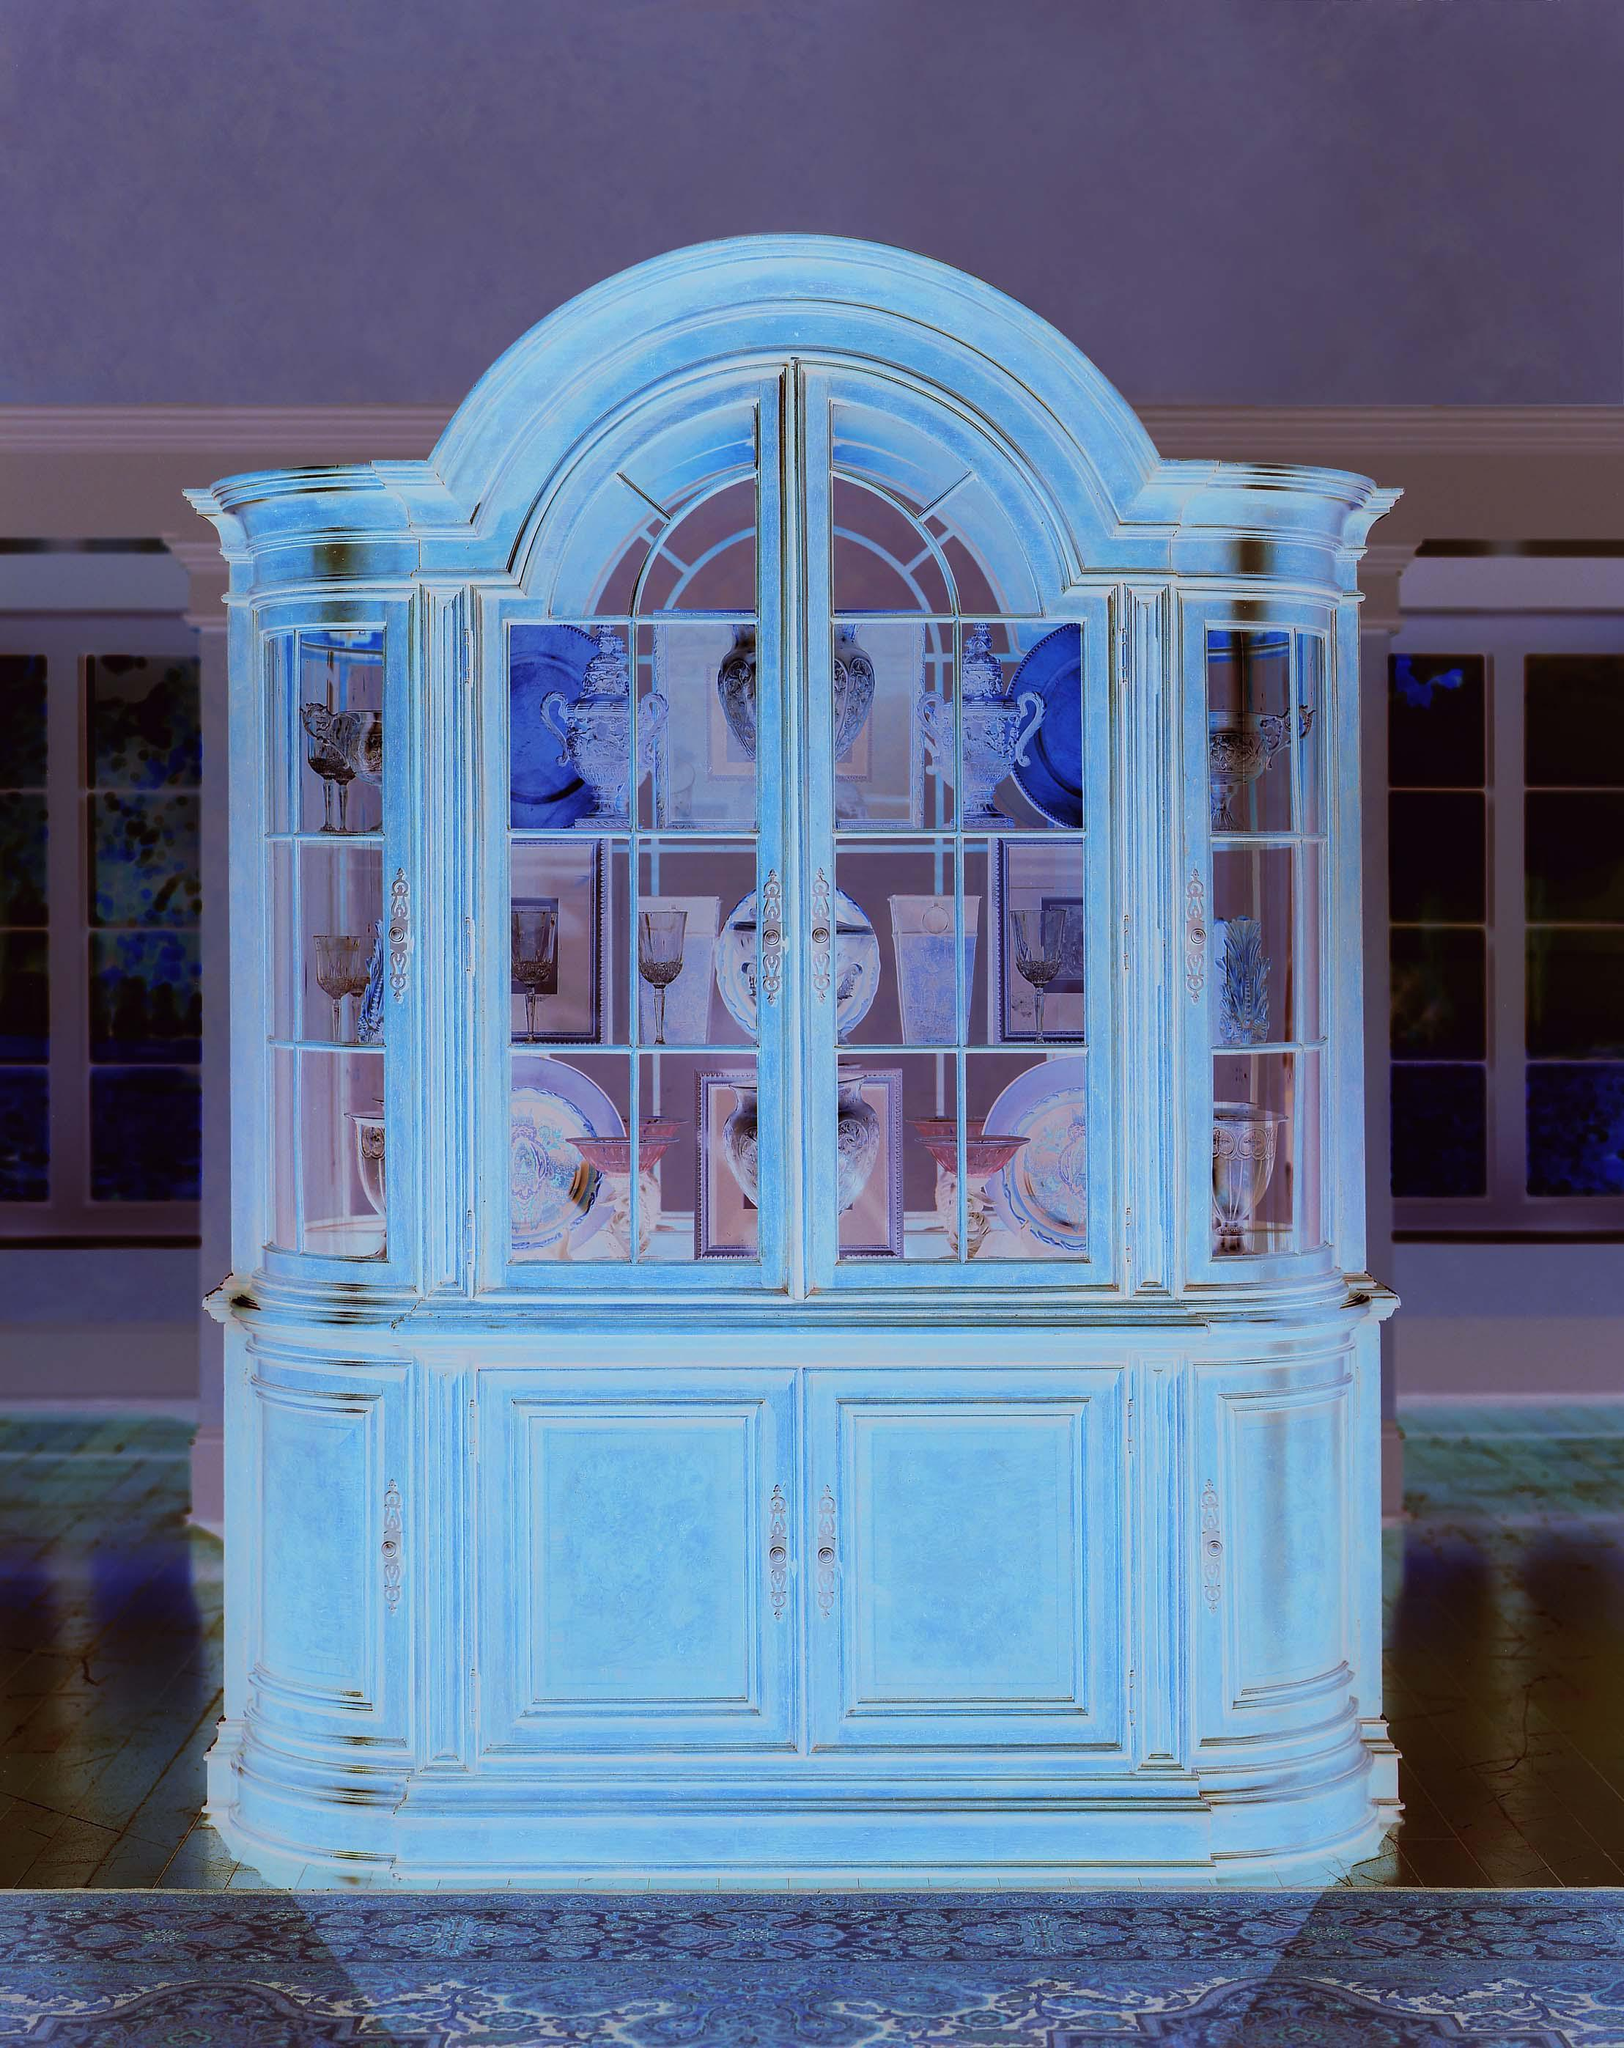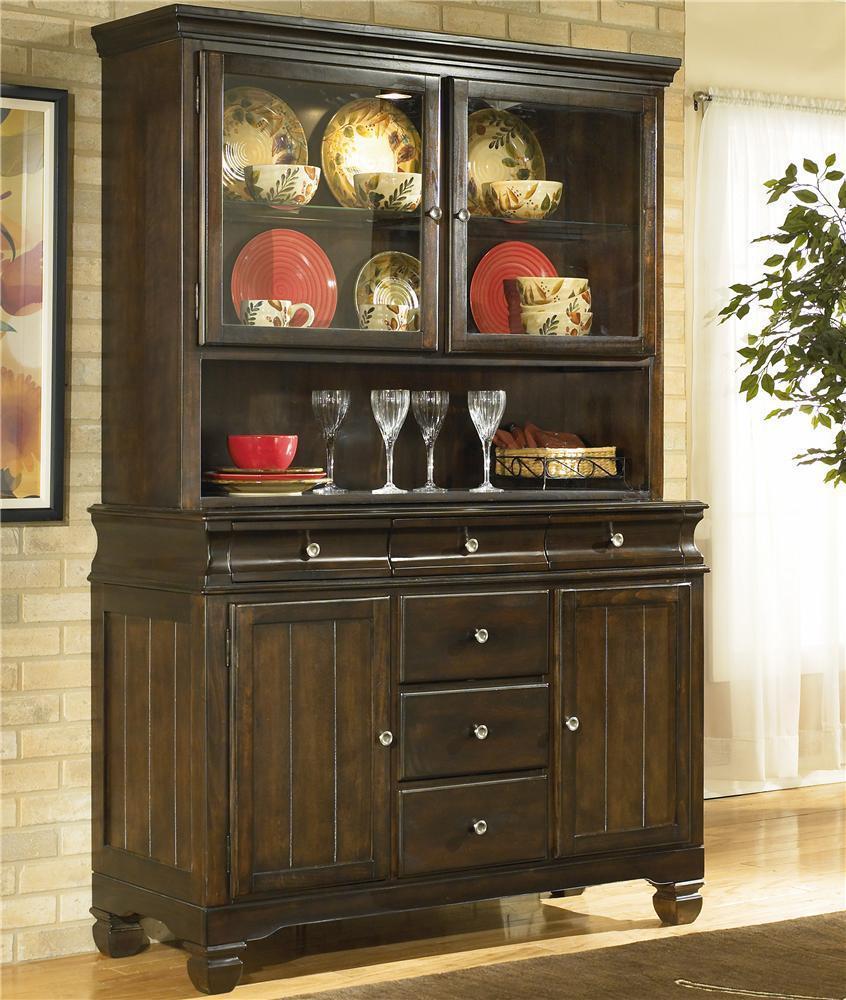The first image is the image on the left, the second image is the image on the right. Assess this claim about the two images: "Two dark hutches have solid wooden doors at the bottom and sit flush to the floor.". Correct or not? Answer yes or no. No. 